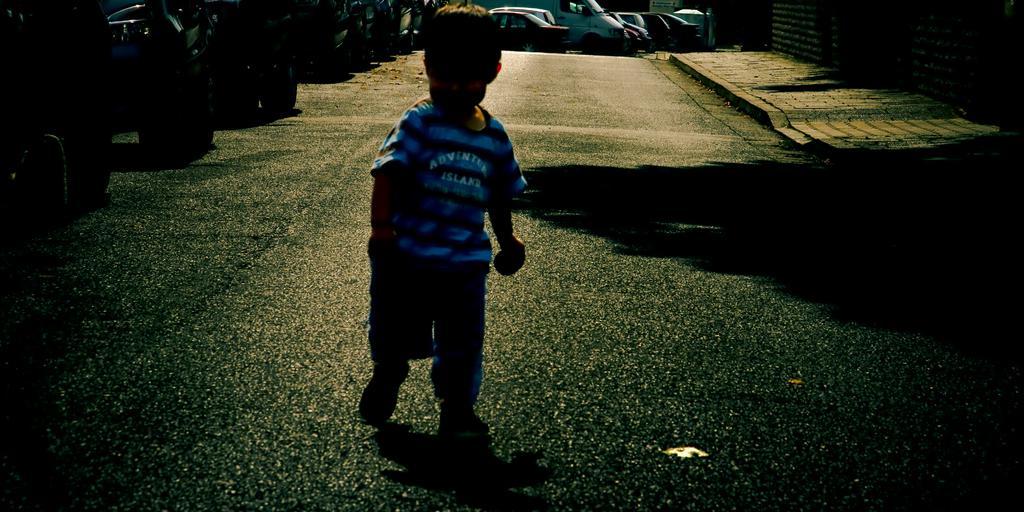Describe this image in one or two sentences. This image consists of a kid wearing a blue T-shirt is walking on the road. At the bottom, there is a road. On the left, there are many cars parked on the road. On the right, there is a pavement. 